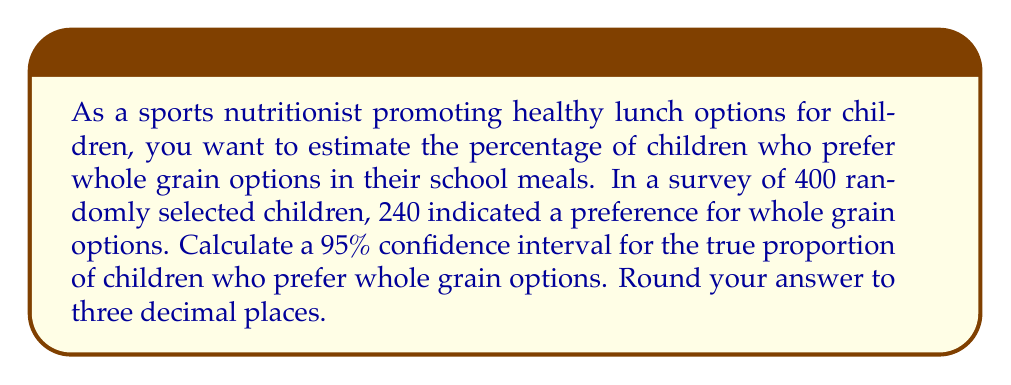Can you answer this question? Let's approach this step-by-step:

1) First, we need to calculate the sample proportion:
   $\hat{p} = \frac{\text{number of successes}}{\text{sample size}} = \frac{240}{400} = 0.6$

2) The formula for the confidence interval is:
   $$\hat{p} \pm z^*\sqrt{\frac{\hat{p}(1-\hat{p})}{n}}$$
   where $z^*$ is the critical value for the desired confidence level.

3) For a 95% confidence interval, $z^* = 1.96$

4) Now, let's calculate the margin of error:
   $$\text{Margin of Error} = 1.96\sqrt{\frac{0.6(1-0.6)}{400}}$$
   $$= 1.96\sqrt{\frac{0.6(0.4)}{400}}$$
   $$= 1.96\sqrt{0.0006}$$
   $$= 1.96(0.0245)$$
   $$= 0.04802$$

5) The confidence interval is then:
   $$0.6 \pm 0.04802$$

6) This gives us:
   Lower bound: $0.6 - 0.04802 = 0.55198$
   Upper bound: $0.6 + 0.04802 = 0.64802$

7) Rounding to three decimal places:
   (0.552, 0.648)
Answer: (0.552, 0.648) 